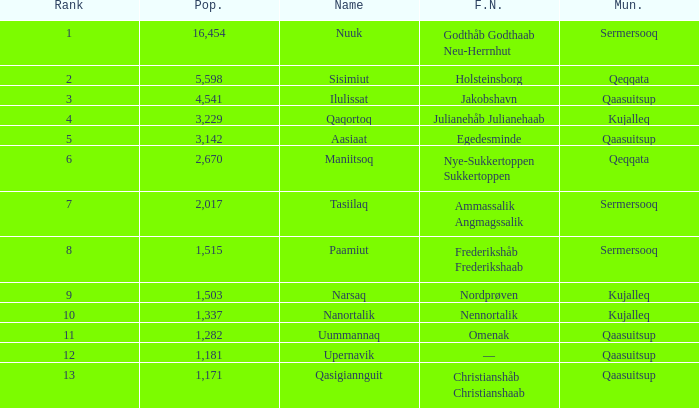What is the population for Rank 11? 1282.0. 